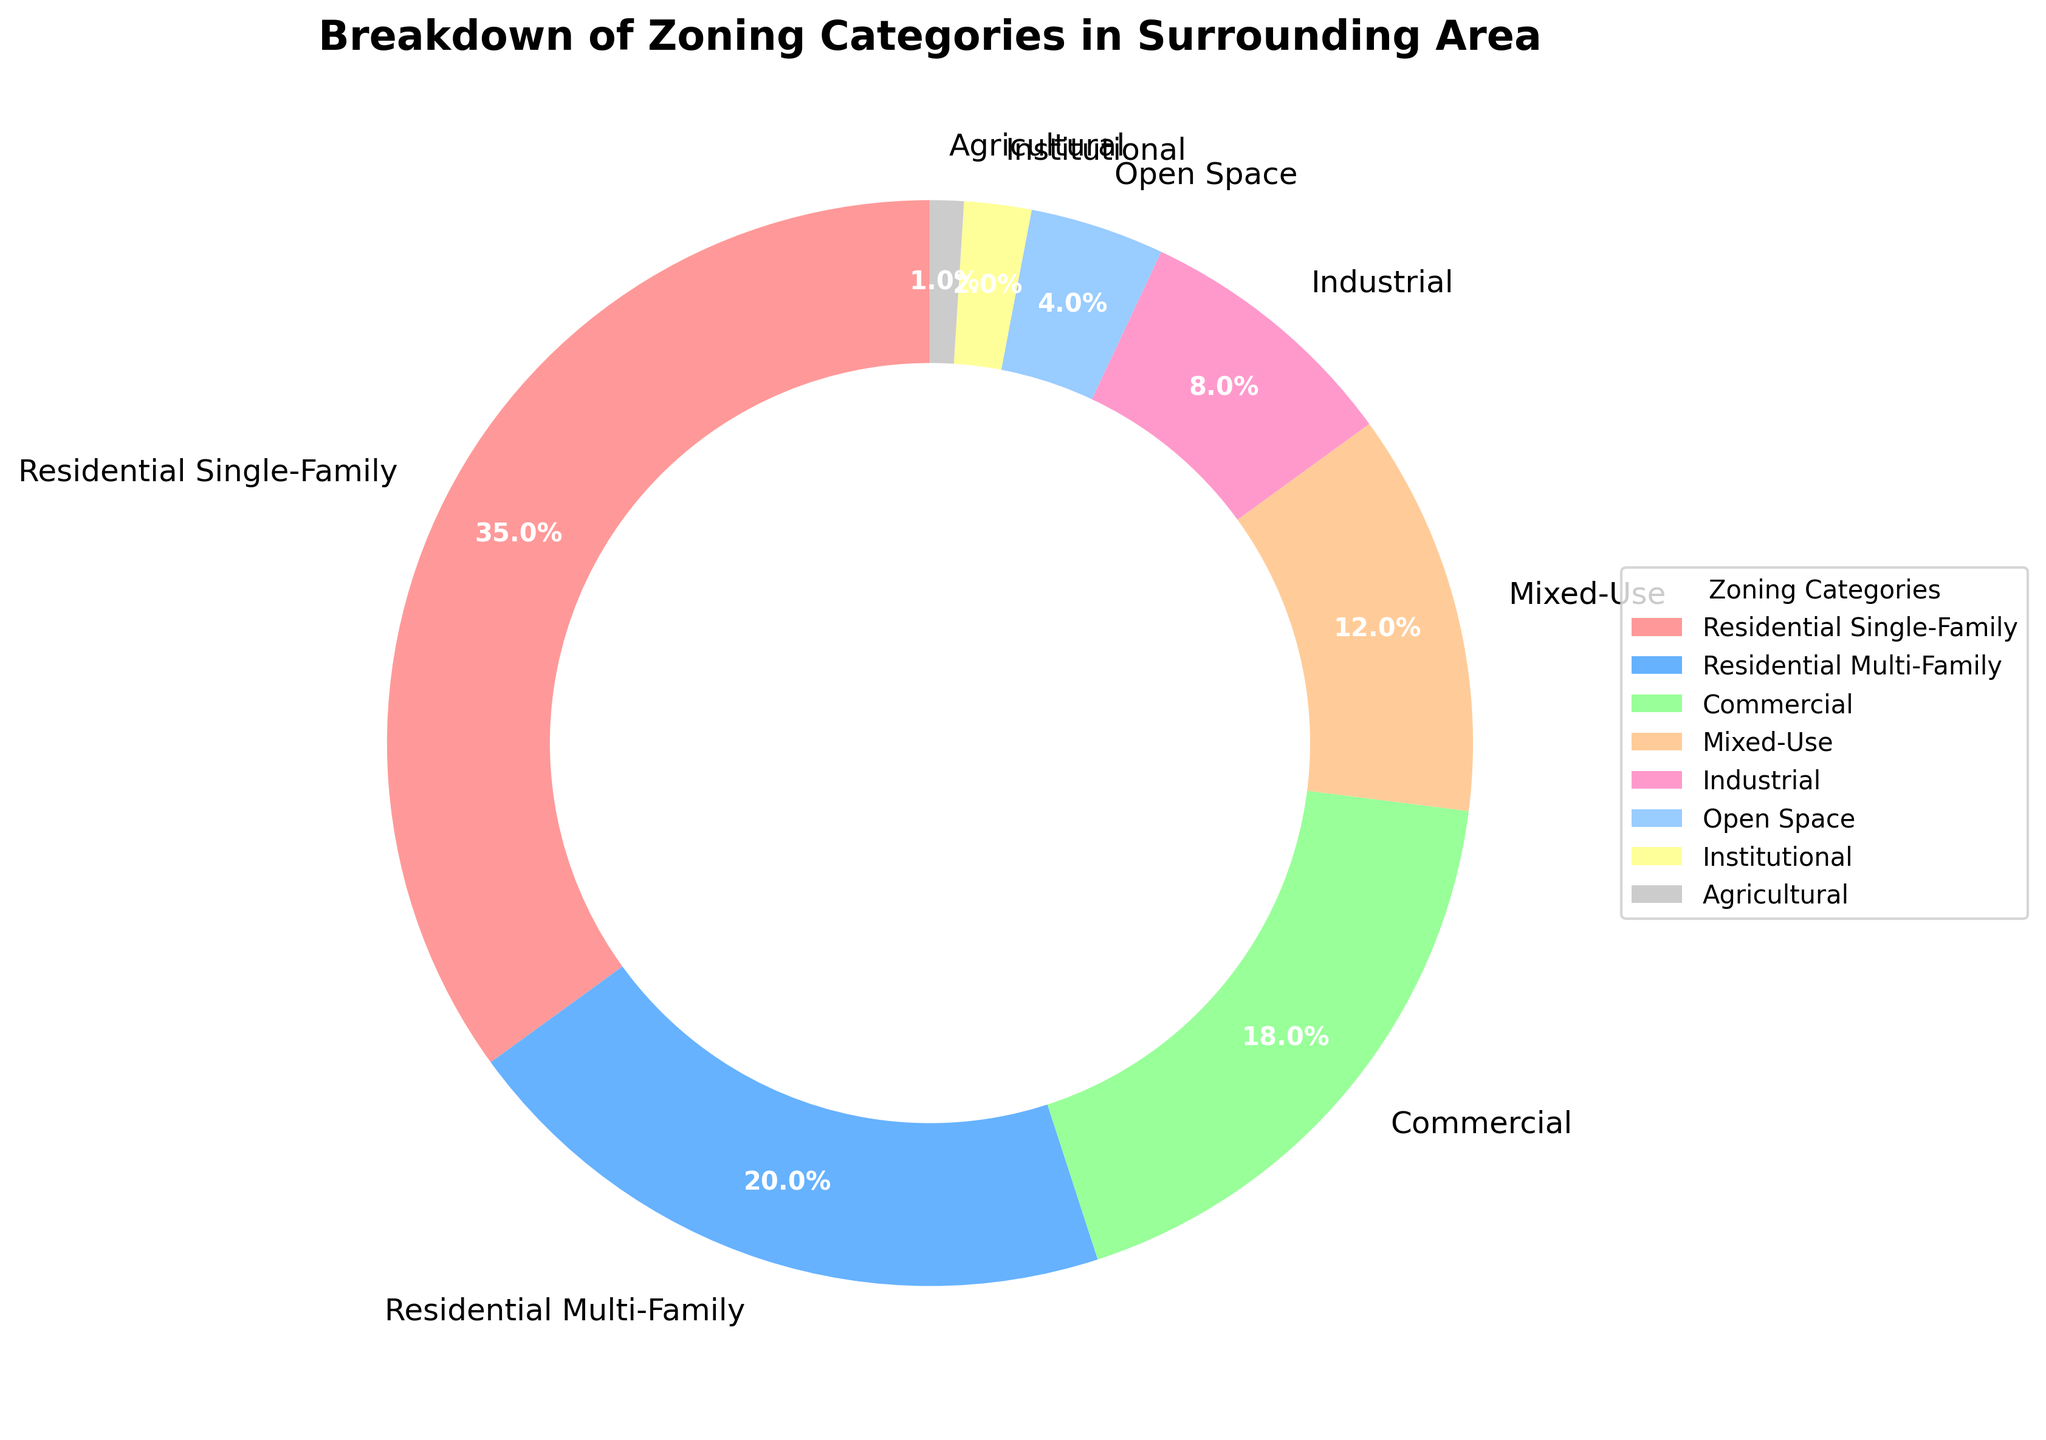Which zoning category has the largest percentage? The largest segment on the pie chart is labeled "Residential Single-Family" with 35%.
Answer: Residential Single-Family What is the combined percentage of Commercial and Mixed-Use zoning categories? The pie chart shows Commercial with 18% and Mixed-Use with 12%. Adding them together: 18% + 12% = 30%.
Answer: 30% Which zoning category has the smallest percentage? The smallest segment on the pie chart is labeled "Agricultural" with 1%.
Answer: Agricultural Is the percentage of Residential Single-Family greater than the combined percentage of Open Space and Institutional? The pie chart shows Residential Single-Family with 35%, Open Space with 4%, and Institutional with 2%. Adding Open Space and Institutional: 4% + 2% = 6%. 35% is greater than 6%.
Answer: Yes What is the percentage difference between Industrial and Institutional zoning categories? The pie chart shows Industrial with 8% and Institutional with 2%. Subtract Institutional from Industrial: 8% - 2% = 6%.
Answer: 6% How does the percentage of Residential Multi-Family compare to the sum of Open Space and Institutional? The pie chart shows Residential Multi-Family with 20%, Open Space with 4%, and Institutional with 2%. Adding Open Space and Institutional: 4% + 2% = 6%. 20% is greater than 6%.
Answer: Greater What are the three zoning categories with the lowest percentages? The three smallest segments on the pie chart are Institutional with 2%, Agricultural with 1%, and Open Space with 4%.
Answer: Institutional, Agricultural, Open Space If you were to combine Mixed-Use and Agricultural, would their total percentage exceed Industrial? The pie chart shows Mixed-Use with 12% and Agricultural with 1%. Adding them together: 12% + 1% = 13%. Industrial is 8%, and 13% is greater than 8%.
Answer: Yes What is the total percentage of the three residential categories? The pie chart shows Residential Single-Family with 35%, Residential Multi-Family with 20%, and Mixed-Use with 12%. Adding them together: 35% + 20% + 12% = 67%.
Answer: 67% Which category has a higher percentage: Commercial or Residential Multi-Family? The pie chart shows Commercial with 18% and Residential Multi-Family with 20%. 20% is greater than 18%.
Answer: Residential Multi-Family 